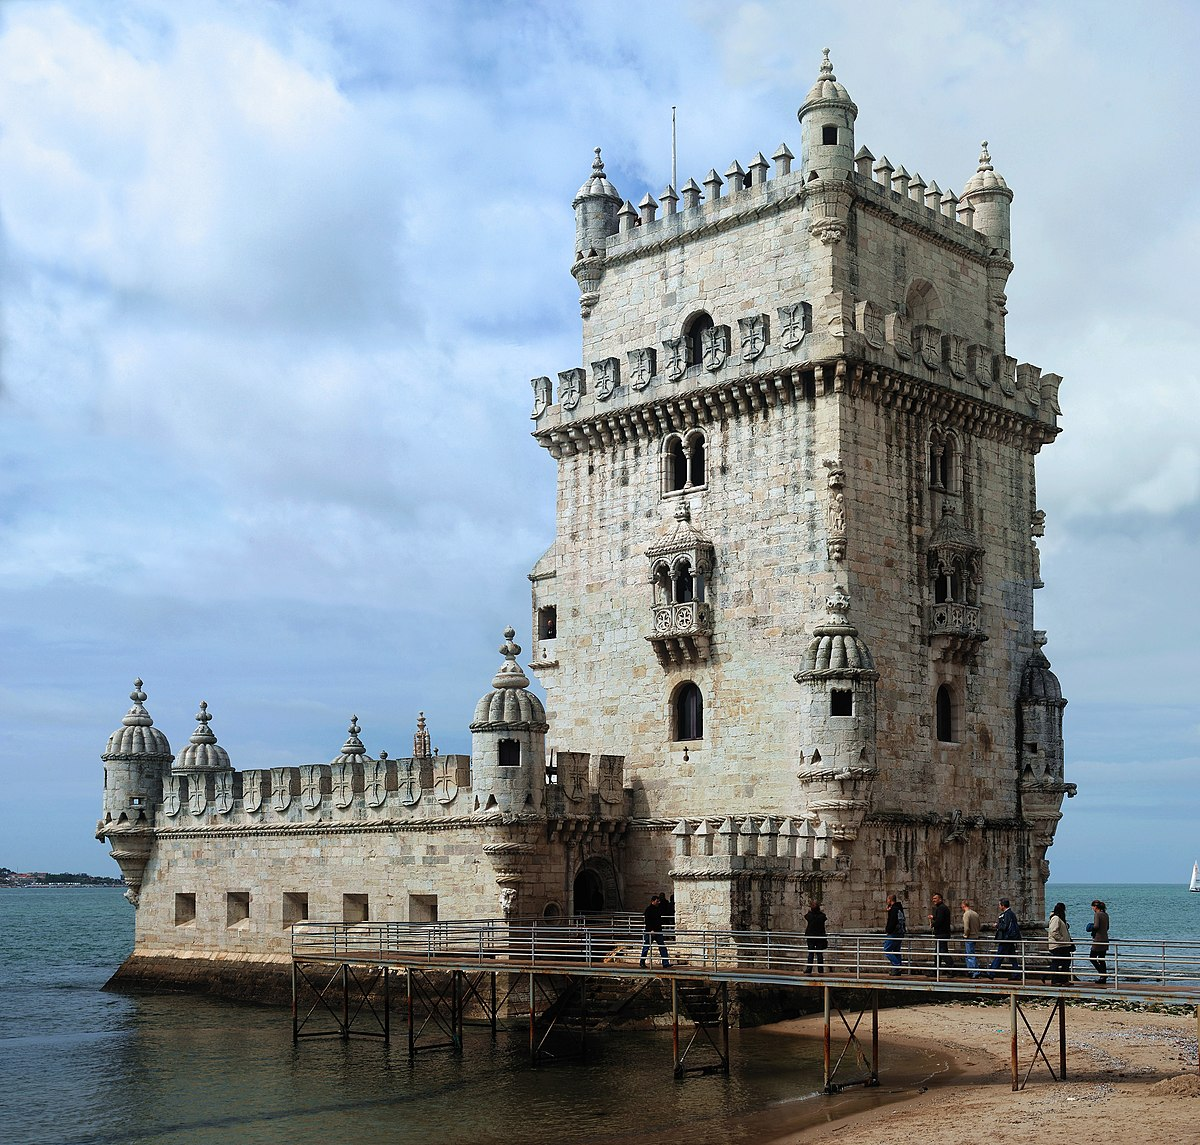What are some architectural details of the Belem Tower that stand out in this image? The Belem Tower is renowned for its Manueline architectural style, which is visible in its lavish decorative motifs that include maritime elements such as armillary spheres, ropes, and crosses of the Order of Christ. Each corner of the tower is fortified with a turret capped with a cupola, which were used for surveillance and defense. The exterior walls are studded with stone-carved ropes and elegant openwork balconies, while the gothic arched windows provide a graceful aesthetic contrast to the robust structure. The façade facing the water features a statue of Our Lady of Safe Homecoming, intended to protect sailors on their voyages. 